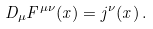Convert formula to latex. <formula><loc_0><loc_0><loc_500><loc_500>D _ { \mu } F ^ { \mu \nu } ( x ) = j ^ { \nu } ( x ) \, .</formula> 